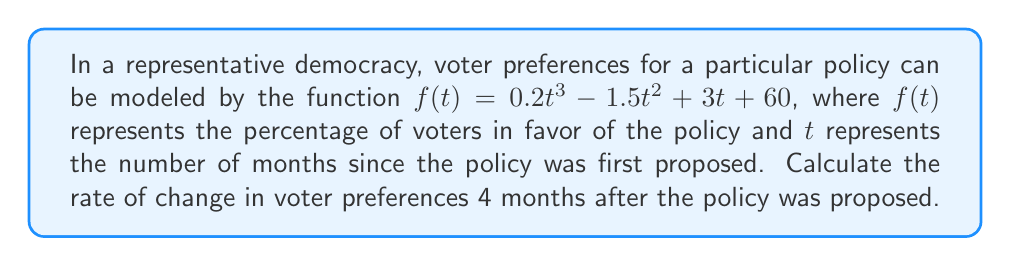Solve this math problem. To solve this problem, we need to follow these steps:

1) The rate of change in voter preferences at a given point is represented by the derivative of the function $f(t)$ at that point.

2) First, let's find the derivative of $f(t)$:
   
   $f(t) = 0.2t^3 - 1.5t^2 + 3t + 60$
   $f'(t) = 0.6t^2 - 3t + 3$

3) Now, we need to evaluate $f'(t)$ at $t = 4$ (4 months after the policy was proposed):

   $f'(4) = 0.6(4)^2 - 3(4) + 3$
          $= 0.6(16) - 12 + 3$
          $= 9.6 - 12 + 3$
          $= 0.6$

4) In the context of this problem, the derivative represents the instantaneous rate of change in the percentage of voters favoring the policy per month.

5) Therefore, 4 months after the policy was proposed, the rate of change in voter preferences is 0.6% per month.
Answer: 0.6% per month 